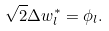<formula> <loc_0><loc_0><loc_500><loc_500>\sqrt { 2 } \Delta w ^ { * } _ { l } = \phi _ { l } .</formula> 